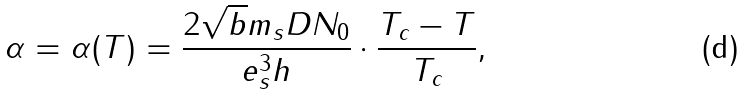Convert formula to latex. <formula><loc_0><loc_0><loc_500><loc_500>\alpha = \alpha ( T ) = \frac { 2 \sqrt { b } m _ { s } D N _ { 0 } } { e ^ { 3 } _ { s } h } \cdot \frac { T _ { c } - T } { T _ { c } } ,</formula> 